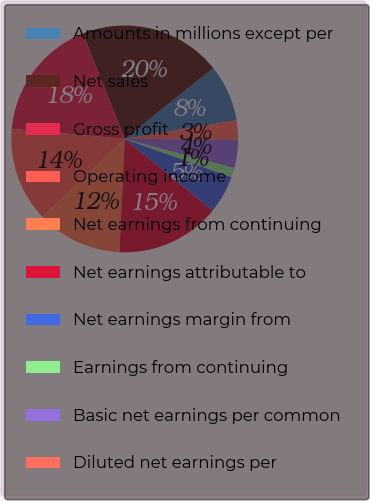Convert chart to OTSL. <chart><loc_0><loc_0><loc_500><loc_500><pie_chart><fcel>Amounts in millions except per<fcel>Net sales<fcel>Gross profit<fcel>Operating income<fcel>Net earnings from continuing<fcel>Net earnings attributable to<fcel>Net earnings margin from<fcel>Earnings from continuing<fcel>Basic net earnings per common<fcel>Diluted net earnings per<nl><fcel>8.11%<fcel>20.27%<fcel>17.57%<fcel>13.51%<fcel>12.16%<fcel>14.86%<fcel>5.41%<fcel>1.35%<fcel>4.05%<fcel>2.7%<nl></chart> 